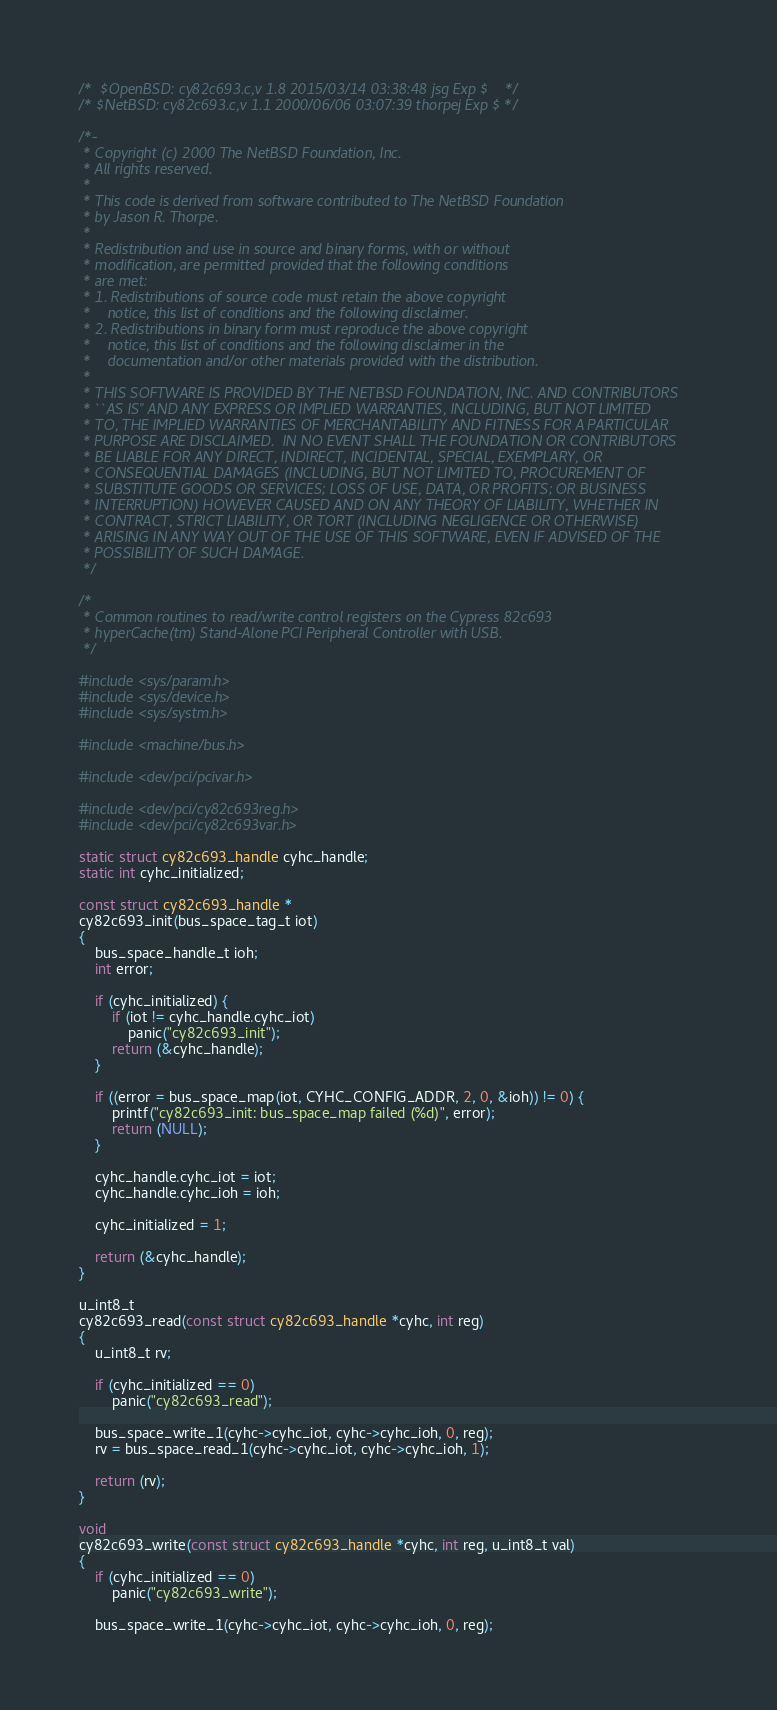<code> <loc_0><loc_0><loc_500><loc_500><_C_>/*	$OpenBSD: cy82c693.c,v 1.8 2015/03/14 03:38:48 jsg Exp $	*/
/* $NetBSD: cy82c693.c,v 1.1 2000/06/06 03:07:39 thorpej Exp $ */

/*-
 * Copyright (c) 2000 The NetBSD Foundation, Inc.
 * All rights reserved.
 *
 * This code is derived from software contributed to The NetBSD Foundation
 * by Jason R. Thorpe.
 *
 * Redistribution and use in source and binary forms, with or without
 * modification, are permitted provided that the following conditions
 * are met:
 * 1. Redistributions of source code must retain the above copyright
 *    notice, this list of conditions and the following disclaimer.
 * 2. Redistributions in binary form must reproduce the above copyright
 *    notice, this list of conditions and the following disclaimer in the
 *    documentation and/or other materials provided with the distribution.
 *
 * THIS SOFTWARE IS PROVIDED BY THE NETBSD FOUNDATION, INC. AND CONTRIBUTORS
 * ``AS IS'' AND ANY EXPRESS OR IMPLIED WARRANTIES, INCLUDING, BUT NOT LIMITED
 * TO, THE IMPLIED WARRANTIES OF MERCHANTABILITY AND FITNESS FOR A PARTICULAR
 * PURPOSE ARE DISCLAIMED.  IN NO EVENT SHALL THE FOUNDATION OR CONTRIBUTORS
 * BE LIABLE FOR ANY DIRECT, INDIRECT, INCIDENTAL, SPECIAL, EXEMPLARY, OR
 * CONSEQUENTIAL DAMAGES (INCLUDING, BUT NOT LIMITED TO, PROCUREMENT OF
 * SUBSTITUTE GOODS OR SERVICES; LOSS OF USE, DATA, OR PROFITS; OR BUSINESS
 * INTERRUPTION) HOWEVER CAUSED AND ON ANY THEORY OF LIABILITY, WHETHER IN
 * CONTRACT, STRICT LIABILITY, OR TORT (INCLUDING NEGLIGENCE OR OTHERWISE)
 * ARISING IN ANY WAY OUT OF THE USE OF THIS SOFTWARE, EVEN IF ADVISED OF THE
 * POSSIBILITY OF SUCH DAMAGE.
 */

/*
 * Common routines to read/write control registers on the Cypress 82c693
 * hyperCache(tm) Stand-Alone PCI Peripheral Controller with USB.
 */

#include <sys/param.h>
#include <sys/device.h>
#include <sys/systm.h>

#include <machine/bus.h>

#include <dev/pci/pcivar.h>

#include <dev/pci/cy82c693reg.h>
#include <dev/pci/cy82c693var.h>

static struct cy82c693_handle cyhc_handle;
static int cyhc_initialized;

const struct cy82c693_handle *
cy82c693_init(bus_space_tag_t iot)
{
	bus_space_handle_t ioh;
	int error;

	if (cyhc_initialized) {
		if (iot != cyhc_handle.cyhc_iot)
			panic("cy82c693_init");
		return (&cyhc_handle);
	}

	if ((error = bus_space_map(iot, CYHC_CONFIG_ADDR, 2, 0, &ioh)) != 0) {
		printf("cy82c693_init: bus_space_map failed (%d)", error);
		return (NULL);
	}

	cyhc_handle.cyhc_iot = iot;
	cyhc_handle.cyhc_ioh = ioh;

	cyhc_initialized = 1;

	return (&cyhc_handle);
}

u_int8_t
cy82c693_read(const struct cy82c693_handle *cyhc, int reg)
{
	u_int8_t rv;

	if (cyhc_initialized == 0)
		panic("cy82c693_read");

	bus_space_write_1(cyhc->cyhc_iot, cyhc->cyhc_ioh, 0, reg);
	rv = bus_space_read_1(cyhc->cyhc_iot, cyhc->cyhc_ioh, 1);

	return (rv);
}

void
cy82c693_write(const struct cy82c693_handle *cyhc, int reg, u_int8_t val)
{
	if (cyhc_initialized == 0)
		panic("cy82c693_write");

	bus_space_write_1(cyhc->cyhc_iot, cyhc->cyhc_ioh, 0, reg);</code> 